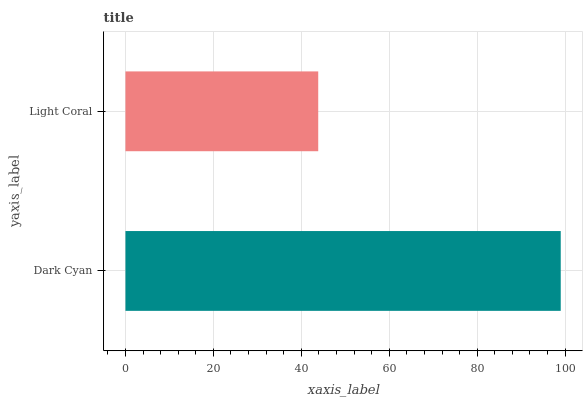Is Light Coral the minimum?
Answer yes or no. Yes. Is Dark Cyan the maximum?
Answer yes or no. Yes. Is Light Coral the maximum?
Answer yes or no. No. Is Dark Cyan greater than Light Coral?
Answer yes or no. Yes. Is Light Coral less than Dark Cyan?
Answer yes or no. Yes. Is Light Coral greater than Dark Cyan?
Answer yes or no. No. Is Dark Cyan less than Light Coral?
Answer yes or no. No. Is Dark Cyan the high median?
Answer yes or no. Yes. Is Light Coral the low median?
Answer yes or no. Yes. Is Light Coral the high median?
Answer yes or no. No. Is Dark Cyan the low median?
Answer yes or no. No. 